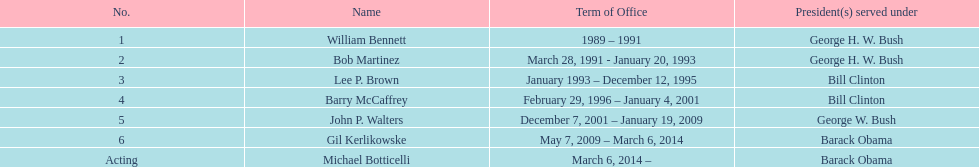What were the number of directors that stayed in office more than three years? 3. 